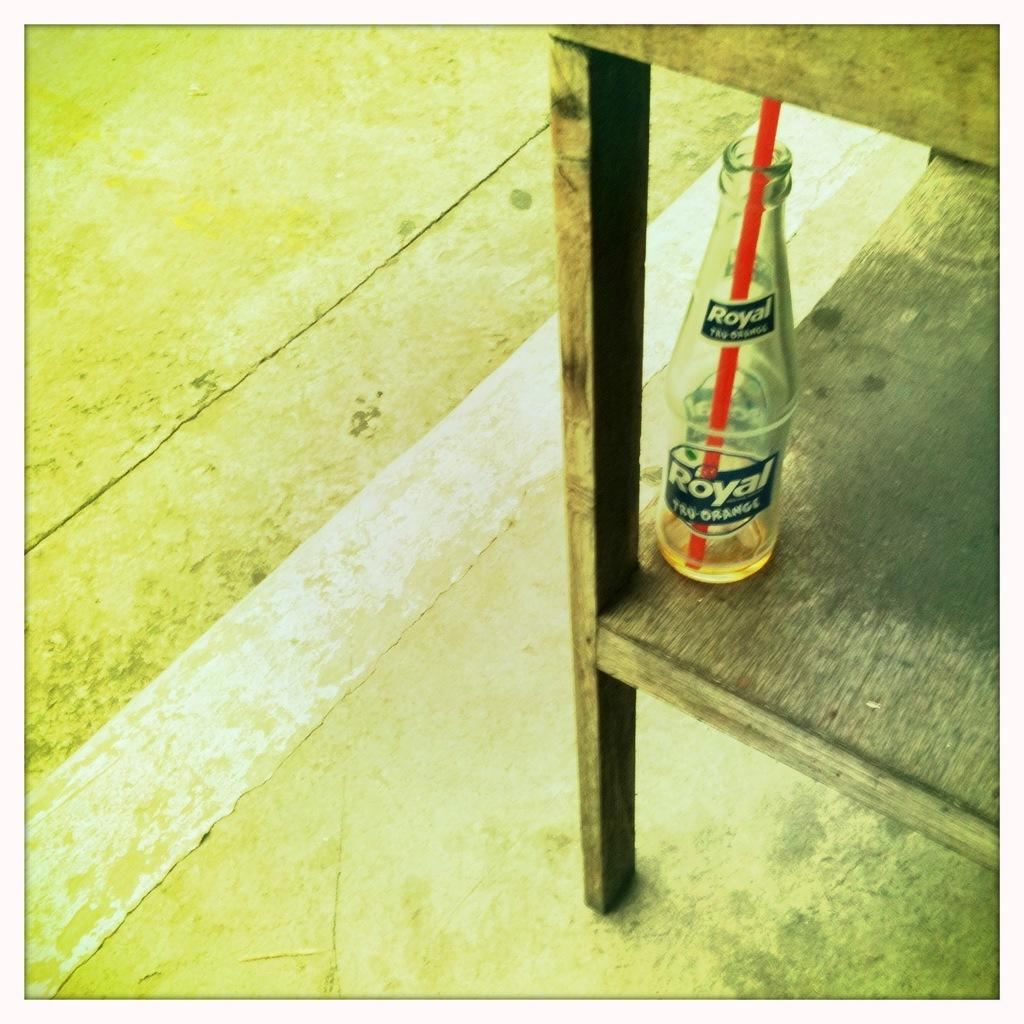<image>
Describe the image concisely. A bottle sitting with a straw in it with the Bottle saying Royal Tru-Orange. 